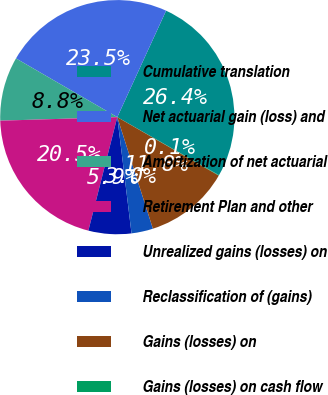Convert chart to OTSL. <chart><loc_0><loc_0><loc_500><loc_500><pie_chart><fcel>Cumulative translation<fcel>Net actuarial gain (loss) and<fcel>Amortization of net actuarial<fcel>Retirement Plan and other<fcel>Unrealized gains (losses) on<fcel>Reclassification of (gains)<fcel>Gains (losses) on<fcel>Gains (losses) on cash flow<nl><fcel>26.41%<fcel>23.48%<fcel>8.84%<fcel>20.55%<fcel>5.91%<fcel>2.98%<fcel>11.77%<fcel>0.06%<nl></chart> 